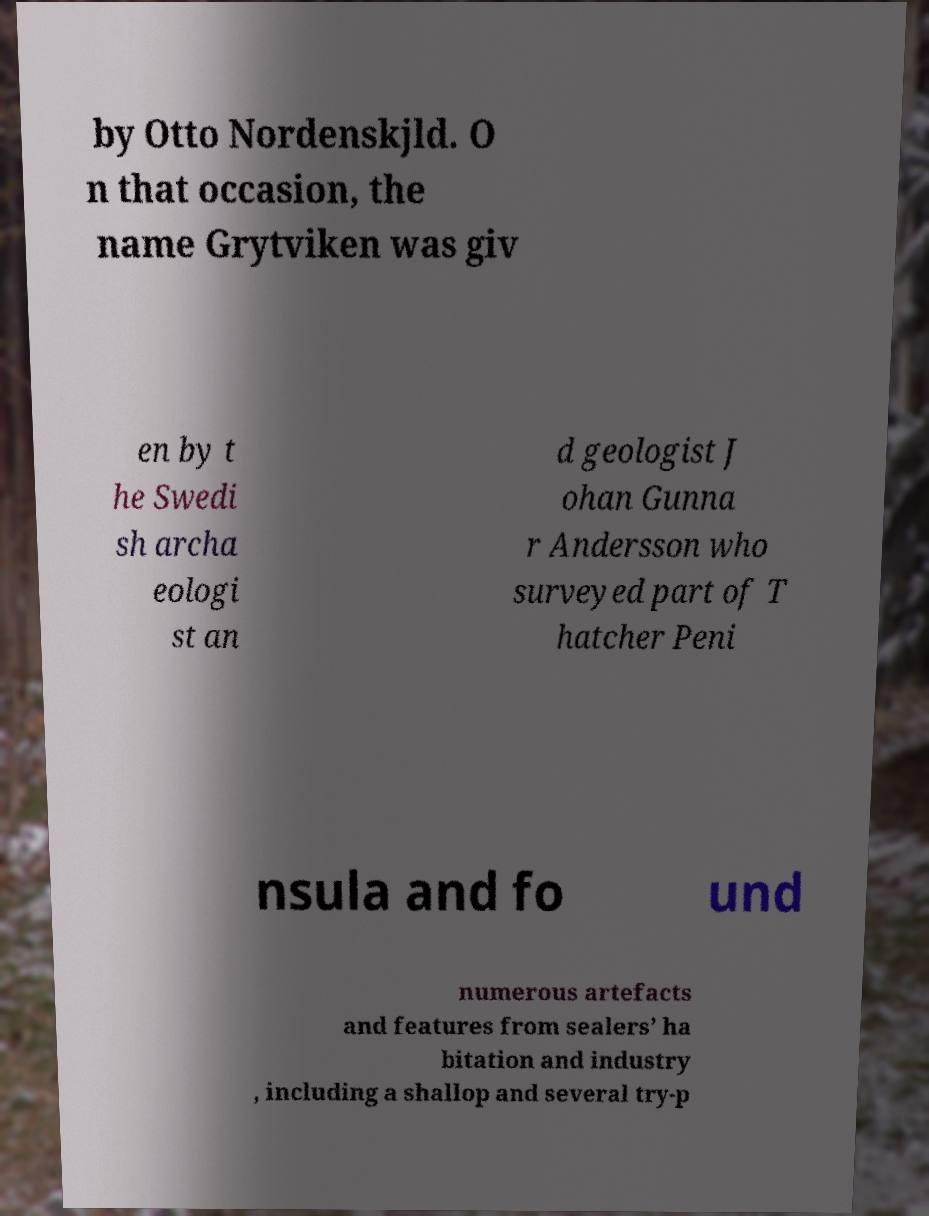I need the written content from this picture converted into text. Can you do that? by Otto Nordenskjld. O n that occasion, the name Grytviken was giv en by t he Swedi sh archa eologi st an d geologist J ohan Gunna r Andersson who surveyed part of T hatcher Peni nsula and fo und numerous artefacts and features from sealers’ ha bitation and industry , including a shallop and several try-p 